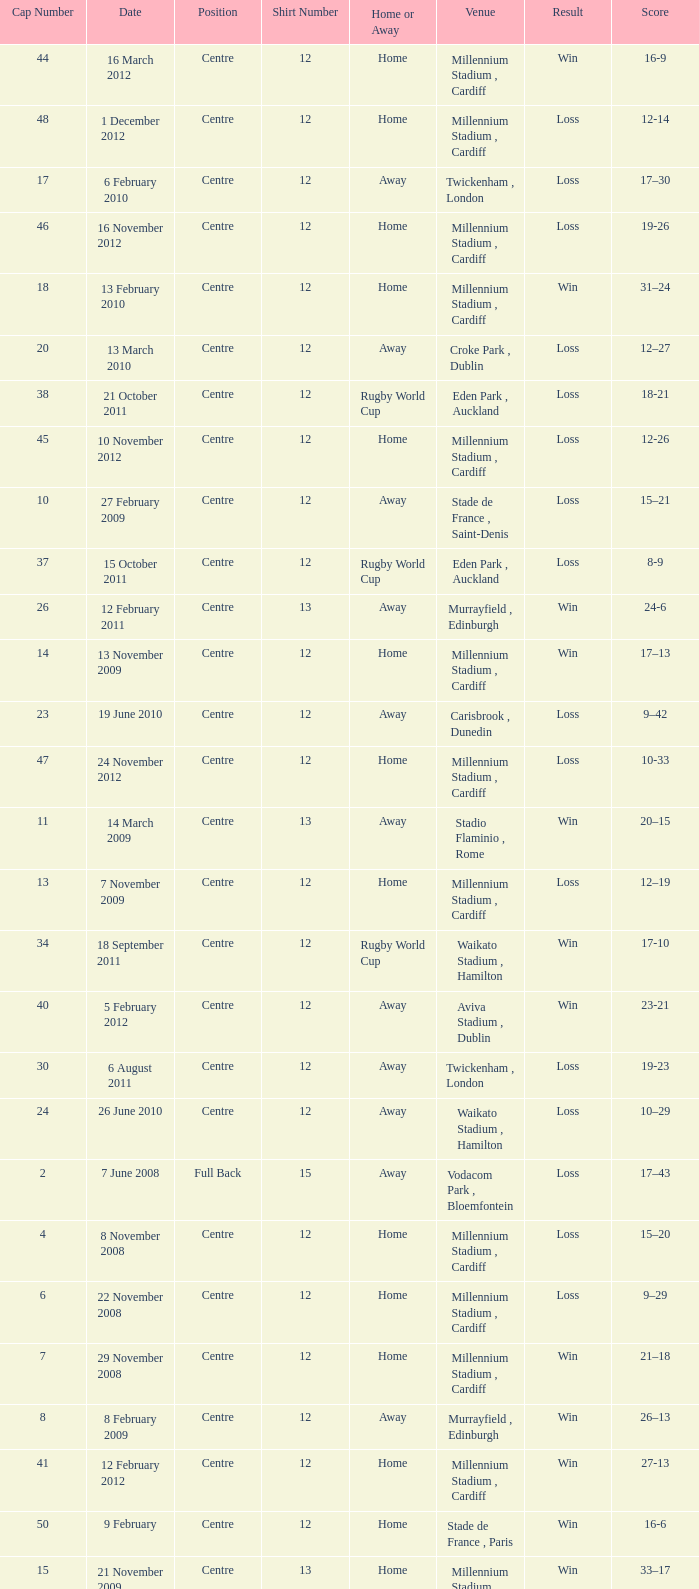What's the largest shirt number when the cap number is 5? 22.0. 